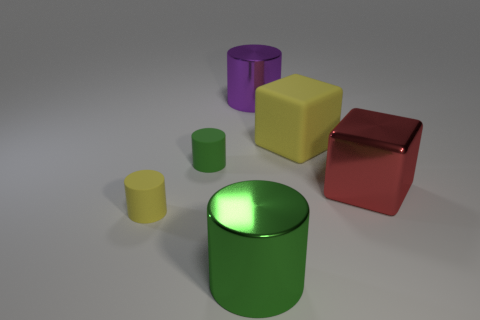Which of the objects shown could be most easily stacked? The cubes would be the easiest to stack due to their flat, even surfaces. 